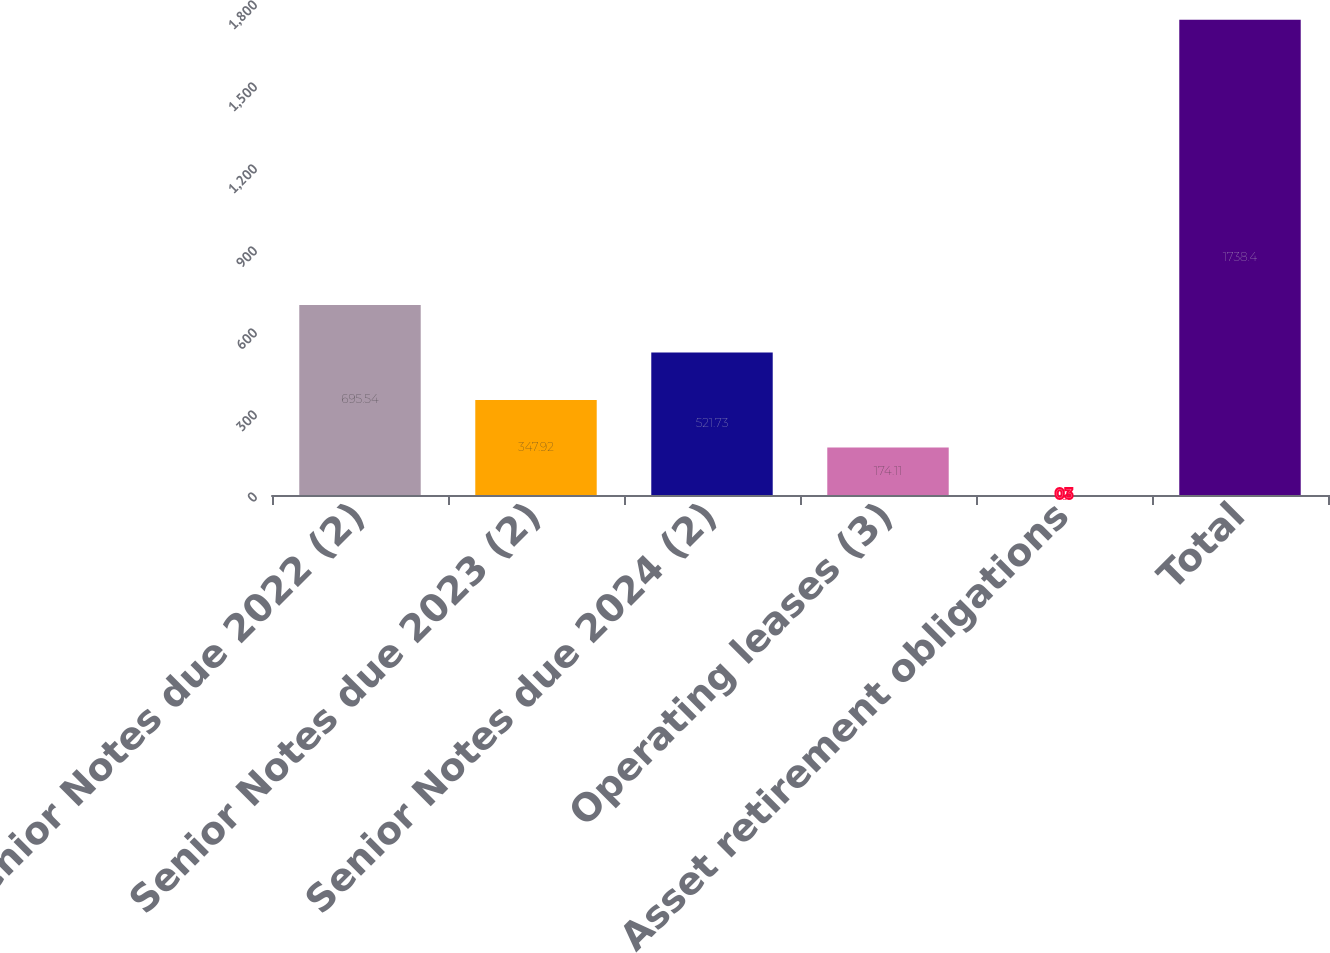Convert chart to OTSL. <chart><loc_0><loc_0><loc_500><loc_500><bar_chart><fcel>Senior Notes due 2022 (2)<fcel>Senior Notes due 2023 (2)<fcel>Senior Notes due 2024 (2)<fcel>Operating leases (3)<fcel>Asset retirement obligations<fcel>Total<nl><fcel>695.54<fcel>347.92<fcel>521.73<fcel>174.11<fcel>0.3<fcel>1738.4<nl></chart> 